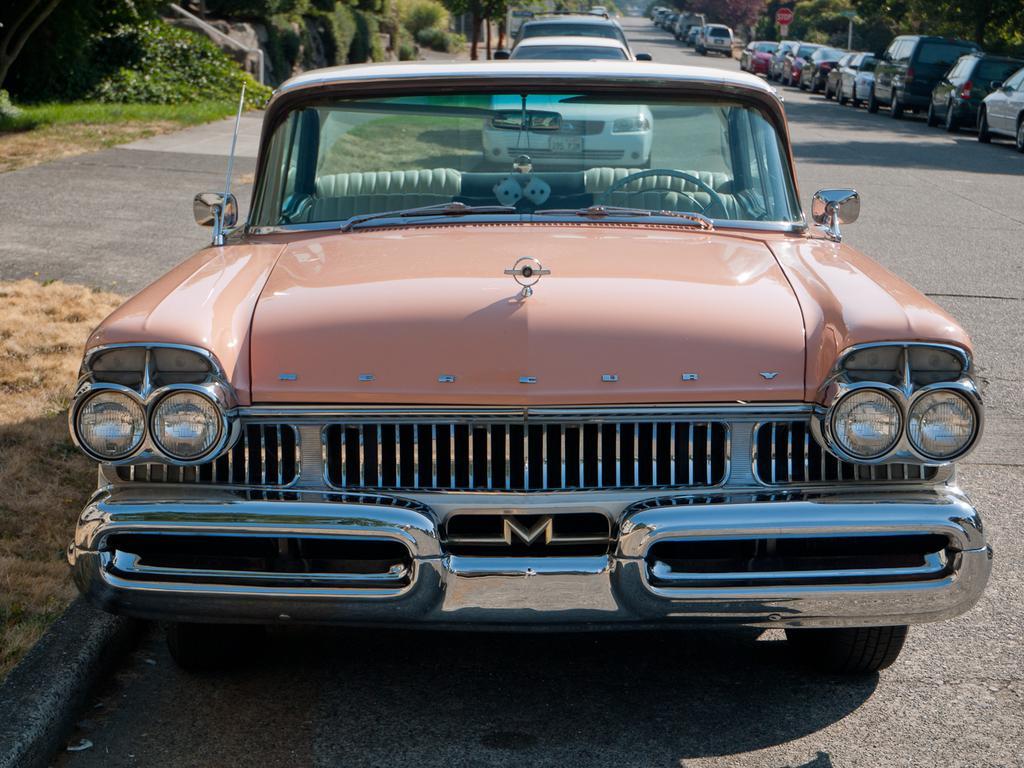Could you give a brief overview of what you see in this image? This picture might be taken from outside of the city and it is sunny. In this image, in the middle, we can see a car which is placed on the road. On the left side, we can see some trees, on the right side, we can also see some cars, trees, hoardings. In the background, we can see some cars which are placed on the road, at the bottom there is a road and a grass. 